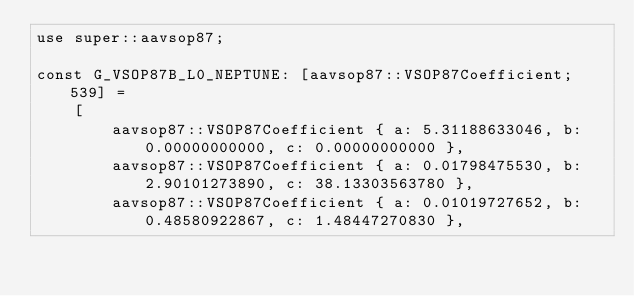<code> <loc_0><loc_0><loc_500><loc_500><_Rust_>use super::aavsop87;

const G_VSOP87B_L0_NEPTUNE: [aavsop87::VSOP87Coefficient; 539] =
    [
        aavsop87::VSOP87Coefficient { a: 5.31188633046, b: 0.00000000000, c: 0.00000000000 },
        aavsop87::VSOP87Coefficient { a: 0.01798475530, b: 2.90101273890, c: 38.13303563780 },
        aavsop87::VSOP87Coefficient { a: 0.01019727652, b: 0.48580922867, c: 1.48447270830 },</code> 